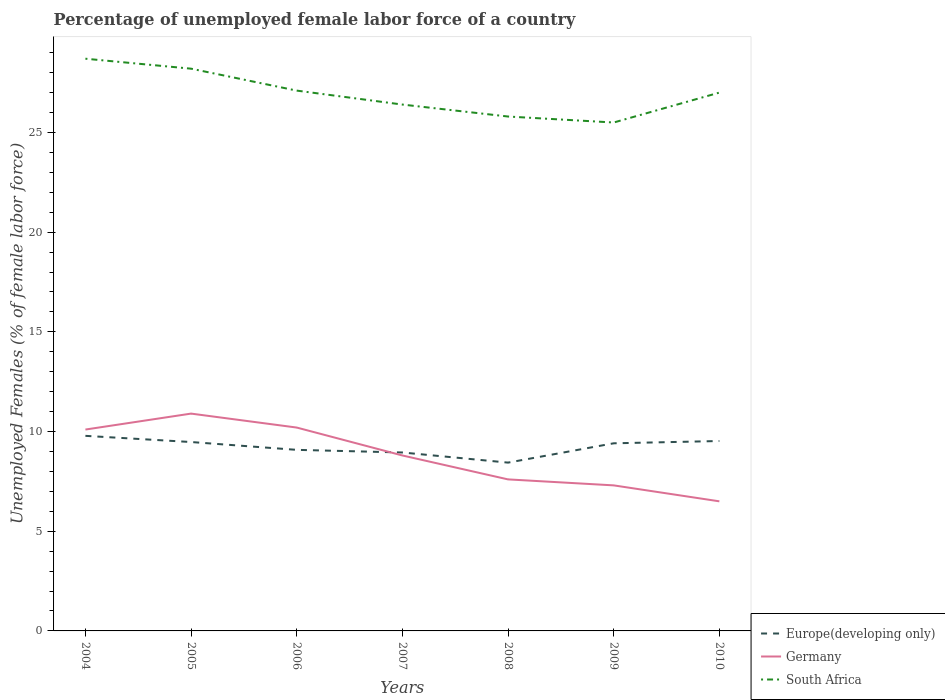How many different coloured lines are there?
Offer a very short reply. 3. Is the number of lines equal to the number of legend labels?
Your answer should be compact. Yes. In which year was the percentage of unemployed female labor force in Europe(developing only) maximum?
Your answer should be very brief. 2008. What is the total percentage of unemployed female labor force in Europe(developing only) in the graph?
Offer a terse response. -0.11. What is the difference between the highest and the second highest percentage of unemployed female labor force in Europe(developing only)?
Your answer should be compact. 1.34. Is the percentage of unemployed female labor force in South Africa strictly greater than the percentage of unemployed female labor force in Germany over the years?
Offer a very short reply. No. What is the difference between two consecutive major ticks on the Y-axis?
Give a very brief answer. 5. Are the values on the major ticks of Y-axis written in scientific E-notation?
Offer a terse response. No. Does the graph contain any zero values?
Give a very brief answer. No. Does the graph contain grids?
Your response must be concise. No. How many legend labels are there?
Offer a terse response. 3. How are the legend labels stacked?
Your answer should be very brief. Vertical. What is the title of the graph?
Keep it short and to the point. Percentage of unemployed female labor force of a country. Does "Cambodia" appear as one of the legend labels in the graph?
Your response must be concise. No. What is the label or title of the Y-axis?
Your response must be concise. Unemployed Females (% of female labor force). What is the Unemployed Females (% of female labor force) of Europe(developing only) in 2004?
Provide a succinct answer. 9.78. What is the Unemployed Females (% of female labor force) in Germany in 2004?
Your answer should be very brief. 10.1. What is the Unemployed Females (% of female labor force) in South Africa in 2004?
Your response must be concise. 28.7. What is the Unemployed Females (% of female labor force) of Europe(developing only) in 2005?
Make the answer very short. 9.47. What is the Unemployed Females (% of female labor force) in Germany in 2005?
Your answer should be compact. 10.9. What is the Unemployed Females (% of female labor force) in South Africa in 2005?
Offer a terse response. 28.2. What is the Unemployed Females (% of female labor force) of Europe(developing only) in 2006?
Provide a short and direct response. 9.08. What is the Unemployed Females (% of female labor force) in Germany in 2006?
Provide a succinct answer. 10.2. What is the Unemployed Females (% of female labor force) of South Africa in 2006?
Offer a terse response. 27.1. What is the Unemployed Females (% of female labor force) of Europe(developing only) in 2007?
Your response must be concise. 8.95. What is the Unemployed Females (% of female labor force) of Germany in 2007?
Give a very brief answer. 8.8. What is the Unemployed Females (% of female labor force) in South Africa in 2007?
Your answer should be compact. 26.4. What is the Unemployed Females (% of female labor force) in Europe(developing only) in 2008?
Make the answer very short. 8.44. What is the Unemployed Females (% of female labor force) in Germany in 2008?
Ensure brevity in your answer.  7.6. What is the Unemployed Females (% of female labor force) of South Africa in 2008?
Provide a short and direct response. 25.8. What is the Unemployed Females (% of female labor force) of Europe(developing only) in 2009?
Offer a very short reply. 9.41. What is the Unemployed Females (% of female labor force) in Germany in 2009?
Ensure brevity in your answer.  7.3. What is the Unemployed Females (% of female labor force) in South Africa in 2009?
Provide a short and direct response. 25.5. What is the Unemployed Females (% of female labor force) of Europe(developing only) in 2010?
Offer a terse response. 9.52. What is the Unemployed Females (% of female labor force) of South Africa in 2010?
Your response must be concise. 27. Across all years, what is the maximum Unemployed Females (% of female labor force) in Europe(developing only)?
Provide a succinct answer. 9.78. Across all years, what is the maximum Unemployed Females (% of female labor force) in Germany?
Your answer should be very brief. 10.9. Across all years, what is the maximum Unemployed Females (% of female labor force) in South Africa?
Give a very brief answer. 28.7. Across all years, what is the minimum Unemployed Females (% of female labor force) of Europe(developing only)?
Your response must be concise. 8.44. Across all years, what is the minimum Unemployed Females (% of female labor force) in Germany?
Give a very brief answer. 6.5. What is the total Unemployed Females (% of female labor force) in Europe(developing only) in the graph?
Ensure brevity in your answer.  64.67. What is the total Unemployed Females (% of female labor force) of Germany in the graph?
Make the answer very short. 61.4. What is the total Unemployed Females (% of female labor force) of South Africa in the graph?
Provide a succinct answer. 188.7. What is the difference between the Unemployed Females (% of female labor force) of Europe(developing only) in 2004 and that in 2005?
Your answer should be very brief. 0.31. What is the difference between the Unemployed Females (% of female labor force) in South Africa in 2004 and that in 2005?
Provide a succinct answer. 0.5. What is the difference between the Unemployed Females (% of female labor force) in Europe(developing only) in 2004 and that in 2006?
Provide a short and direct response. 0.7. What is the difference between the Unemployed Females (% of female labor force) in South Africa in 2004 and that in 2006?
Ensure brevity in your answer.  1.6. What is the difference between the Unemployed Females (% of female labor force) in Europe(developing only) in 2004 and that in 2007?
Give a very brief answer. 0.83. What is the difference between the Unemployed Females (% of female labor force) in Germany in 2004 and that in 2007?
Make the answer very short. 1.3. What is the difference between the Unemployed Females (% of female labor force) in Europe(developing only) in 2004 and that in 2008?
Keep it short and to the point. 1.34. What is the difference between the Unemployed Females (% of female labor force) in Germany in 2004 and that in 2008?
Provide a succinct answer. 2.5. What is the difference between the Unemployed Females (% of female labor force) in South Africa in 2004 and that in 2008?
Ensure brevity in your answer.  2.9. What is the difference between the Unemployed Females (% of female labor force) in Europe(developing only) in 2004 and that in 2009?
Your answer should be very brief. 0.37. What is the difference between the Unemployed Females (% of female labor force) in Germany in 2004 and that in 2009?
Provide a succinct answer. 2.8. What is the difference between the Unemployed Females (% of female labor force) in South Africa in 2004 and that in 2009?
Provide a short and direct response. 3.2. What is the difference between the Unemployed Females (% of female labor force) in Europe(developing only) in 2004 and that in 2010?
Your answer should be very brief. 0.26. What is the difference between the Unemployed Females (% of female labor force) in South Africa in 2004 and that in 2010?
Ensure brevity in your answer.  1.7. What is the difference between the Unemployed Females (% of female labor force) of Europe(developing only) in 2005 and that in 2006?
Your response must be concise. 0.39. What is the difference between the Unemployed Females (% of female labor force) of Germany in 2005 and that in 2006?
Your response must be concise. 0.7. What is the difference between the Unemployed Females (% of female labor force) in South Africa in 2005 and that in 2006?
Offer a very short reply. 1.1. What is the difference between the Unemployed Females (% of female labor force) in Europe(developing only) in 2005 and that in 2007?
Your answer should be very brief. 0.52. What is the difference between the Unemployed Females (% of female labor force) in Germany in 2005 and that in 2007?
Your answer should be compact. 2.1. What is the difference between the Unemployed Females (% of female labor force) of Europe(developing only) in 2005 and that in 2008?
Your response must be concise. 1.03. What is the difference between the Unemployed Females (% of female labor force) in Germany in 2005 and that in 2008?
Make the answer very short. 3.3. What is the difference between the Unemployed Females (% of female labor force) of South Africa in 2005 and that in 2008?
Offer a very short reply. 2.4. What is the difference between the Unemployed Females (% of female labor force) in Europe(developing only) in 2005 and that in 2009?
Keep it short and to the point. 0.06. What is the difference between the Unemployed Females (% of female labor force) in Germany in 2005 and that in 2009?
Give a very brief answer. 3.6. What is the difference between the Unemployed Females (% of female labor force) in South Africa in 2005 and that in 2009?
Offer a very short reply. 2.7. What is the difference between the Unemployed Females (% of female labor force) of Europe(developing only) in 2005 and that in 2010?
Offer a very short reply. -0.05. What is the difference between the Unemployed Females (% of female labor force) of Germany in 2005 and that in 2010?
Provide a succinct answer. 4.4. What is the difference between the Unemployed Females (% of female labor force) of South Africa in 2005 and that in 2010?
Your response must be concise. 1.2. What is the difference between the Unemployed Females (% of female labor force) of Europe(developing only) in 2006 and that in 2007?
Your answer should be compact. 0.13. What is the difference between the Unemployed Females (% of female labor force) in Europe(developing only) in 2006 and that in 2008?
Keep it short and to the point. 0.64. What is the difference between the Unemployed Females (% of female labor force) of Germany in 2006 and that in 2008?
Your answer should be very brief. 2.6. What is the difference between the Unemployed Females (% of female labor force) in Europe(developing only) in 2006 and that in 2009?
Your response must be concise. -0.33. What is the difference between the Unemployed Females (% of female labor force) in Germany in 2006 and that in 2009?
Give a very brief answer. 2.9. What is the difference between the Unemployed Females (% of female labor force) of Europe(developing only) in 2006 and that in 2010?
Keep it short and to the point. -0.44. What is the difference between the Unemployed Females (% of female labor force) of South Africa in 2006 and that in 2010?
Offer a terse response. 0.1. What is the difference between the Unemployed Females (% of female labor force) of Europe(developing only) in 2007 and that in 2008?
Give a very brief answer. 0.51. What is the difference between the Unemployed Females (% of female labor force) in Germany in 2007 and that in 2008?
Provide a short and direct response. 1.2. What is the difference between the Unemployed Females (% of female labor force) in South Africa in 2007 and that in 2008?
Your response must be concise. 0.6. What is the difference between the Unemployed Females (% of female labor force) of Europe(developing only) in 2007 and that in 2009?
Keep it short and to the point. -0.46. What is the difference between the Unemployed Females (% of female labor force) of South Africa in 2007 and that in 2009?
Make the answer very short. 0.9. What is the difference between the Unemployed Females (% of female labor force) in Europe(developing only) in 2007 and that in 2010?
Provide a short and direct response. -0.58. What is the difference between the Unemployed Females (% of female labor force) of Germany in 2007 and that in 2010?
Offer a terse response. 2.3. What is the difference between the Unemployed Females (% of female labor force) of Europe(developing only) in 2008 and that in 2009?
Your response must be concise. -0.97. What is the difference between the Unemployed Females (% of female labor force) of South Africa in 2008 and that in 2009?
Your answer should be very brief. 0.3. What is the difference between the Unemployed Females (% of female labor force) of Europe(developing only) in 2008 and that in 2010?
Offer a very short reply. -1.08. What is the difference between the Unemployed Females (% of female labor force) in South Africa in 2008 and that in 2010?
Offer a terse response. -1.2. What is the difference between the Unemployed Females (% of female labor force) in Europe(developing only) in 2009 and that in 2010?
Give a very brief answer. -0.11. What is the difference between the Unemployed Females (% of female labor force) of Germany in 2009 and that in 2010?
Your answer should be compact. 0.8. What is the difference between the Unemployed Females (% of female labor force) of South Africa in 2009 and that in 2010?
Ensure brevity in your answer.  -1.5. What is the difference between the Unemployed Females (% of female labor force) in Europe(developing only) in 2004 and the Unemployed Females (% of female labor force) in Germany in 2005?
Keep it short and to the point. -1.12. What is the difference between the Unemployed Females (% of female labor force) of Europe(developing only) in 2004 and the Unemployed Females (% of female labor force) of South Africa in 2005?
Your answer should be compact. -18.42. What is the difference between the Unemployed Females (% of female labor force) in Germany in 2004 and the Unemployed Females (% of female labor force) in South Africa in 2005?
Your answer should be compact. -18.1. What is the difference between the Unemployed Females (% of female labor force) in Europe(developing only) in 2004 and the Unemployed Females (% of female labor force) in Germany in 2006?
Offer a very short reply. -0.42. What is the difference between the Unemployed Females (% of female labor force) in Europe(developing only) in 2004 and the Unemployed Females (% of female labor force) in South Africa in 2006?
Provide a short and direct response. -17.32. What is the difference between the Unemployed Females (% of female labor force) in Germany in 2004 and the Unemployed Females (% of female labor force) in South Africa in 2006?
Offer a very short reply. -17. What is the difference between the Unemployed Females (% of female labor force) in Europe(developing only) in 2004 and the Unemployed Females (% of female labor force) in Germany in 2007?
Your answer should be compact. 0.98. What is the difference between the Unemployed Females (% of female labor force) in Europe(developing only) in 2004 and the Unemployed Females (% of female labor force) in South Africa in 2007?
Offer a terse response. -16.62. What is the difference between the Unemployed Females (% of female labor force) in Germany in 2004 and the Unemployed Females (% of female labor force) in South Africa in 2007?
Give a very brief answer. -16.3. What is the difference between the Unemployed Females (% of female labor force) in Europe(developing only) in 2004 and the Unemployed Females (% of female labor force) in Germany in 2008?
Your answer should be compact. 2.18. What is the difference between the Unemployed Females (% of female labor force) of Europe(developing only) in 2004 and the Unemployed Females (% of female labor force) of South Africa in 2008?
Provide a short and direct response. -16.02. What is the difference between the Unemployed Females (% of female labor force) in Germany in 2004 and the Unemployed Females (% of female labor force) in South Africa in 2008?
Offer a terse response. -15.7. What is the difference between the Unemployed Females (% of female labor force) in Europe(developing only) in 2004 and the Unemployed Females (% of female labor force) in Germany in 2009?
Your response must be concise. 2.48. What is the difference between the Unemployed Females (% of female labor force) of Europe(developing only) in 2004 and the Unemployed Females (% of female labor force) of South Africa in 2009?
Ensure brevity in your answer.  -15.72. What is the difference between the Unemployed Females (% of female labor force) in Germany in 2004 and the Unemployed Females (% of female labor force) in South Africa in 2009?
Your answer should be very brief. -15.4. What is the difference between the Unemployed Females (% of female labor force) in Europe(developing only) in 2004 and the Unemployed Females (% of female labor force) in Germany in 2010?
Give a very brief answer. 3.28. What is the difference between the Unemployed Females (% of female labor force) of Europe(developing only) in 2004 and the Unemployed Females (% of female labor force) of South Africa in 2010?
Keep it short and to the point. -17.22. What is the difference between the Unemployed Females (% of female labor force) in Germany in 2004 and the Unemployed Females (% of female labor force) in South Africa in 2010?
Provide a succinct answer. -16.9. What is the difference between the Unemployed Females (% of female labor force) in Europe(developing only) in 2005 and the Unemployed Females (% of female labor force) in Germany in 2006?
Offer a terse response. -0.73. What is the difference between the Unemployed Females (% of female labor force) of Europe(developing only) in 2005 and the Unemployed Females (% of female labor force) of South Africa in 2006?
Offer a very short reply. -17.63. What is the difference between the Unemployed Females (% of female labor force) of Germany in 2005 and the Unemployed Females (% of female labor force) of South Africa in 2006?
Your answer should be compact. -16.2. What is the difference between the Unemployed Females (% of female labor force) in Europe(developing only) in 2005 and the Unemployed Females (% of female labor force) in Germany in 2007?
Give a very brief answer. 0.67. What is the difference between the Unemployed Females (% of female labor force) in Europe(developing only) in 2005 and the Unemployed Females (% of female labor force) in South Africa in 2007?
Make the answer very short. -16.93. What is the difference between the Unemployed Females (% of female labor force) in Germany in 2005 and the Unemployed Females (% of female labor force) in South Africa in 2007?
Keep it short and to the point. -15.5. What is the difference between the Unemployed Females (% of female labor force) of Europe(developing only) in 2005 and the Unemployed Females (% of female labor force) of Germany in 2008?
Ensure brevity in your answer.  1.87. What is the difference between the Unemployed Females (% of female labor force) in Europe(developing only) in 2005 and the Unemployed Females (% of female labor force) in South Africa in 2008?
Your answer should be very brief. -16.33. What is the difference between the Unemployed Females (% of female labor force) of Germany in 2005 and the Unemployed Females (% of female labor force) of South Africa in 2008?
Your answer should be compact. -14.9. What is the difference between the Unemployed Females (% of female labor force) in Europe(developing only) in 2005 and the Unemployed Females (% of female labor force) in Germany in 2009?
Make the answer very short. 2.17. What is the difference between the Unemployed Females (% of female labor force) in Europe(developing only) in 2005 and the Unemployed Females (% of female labor force) in South Africa in 2009?
Your response must be concise. -16.03. What is the difference between the Unemployed Females (% of female labor force) in Germany in 2005 and the Unemployed Females (% of female labor force) in South Africa in 2009?
Provide a succinct answer. -14.6. What is the difference between the Unemployed Females (% of female labor force) in Europe(developing only) in 2005 and the Unemployed Females (% of female labor force) in Germany in 2010?
Your response must be concise. 2.97. What is the difference between the Unemployed Females (% of female labor force) of Europe(developing only) in 2005 and the Unemployed Females (% of female labor force) of South Africa in 2010?
Make the answer very short. -17.53. What is the difference between the Unemployed Females (% of female labor force) in Germany in 2005 and the Unemployed Females (% of female labor force) in South Africa in 2010?
Offer a very short reply. -16.1. What is the difference between the Unemployed Females (% of female labor force) in Europe(developing only) in 2006 and the Unemployed Females (% of female labor force) in Germany in 2007?
Provide a succinct answer. 0.28. What is the difference between the Unemployed Females (% of female labor force) in Europe(developing only) in 2006 and the Unemployed Females (% of female labor force) in South Africa in 2007?
Your response must be concise. -17.32. What is the difference between the Unemployed Females (% of female labor force) of Germany in 2006 and the Unemployed Females (% of female labor force) of South Africa in 2007?
Make the answer very short. -16.2. What is the difference between the Unemployed Females (% of female labor force) of Europe(developing only) in 2006 and the Unemployed Females (% of female labor force) of Germany in 2008?
Your answer should be very brief. 1.48. What is the difference between the Unemployed Females (% of female labor force) in Europe(developing only) in 2006 and the Unemployed Females (% of female labor force) in South Africa in 2008?
Provide a succinct answer. -16.72. What is the difference between the Unemployed Females (% of female labor force) in Germany in 2006 and the Unemployed Females (% of female labor force) in South Africa in 2008?
Ensure brevity in your answer.  -15.6. What is the difference between the Unemployed Females (% of female labor force) of Europe(developing only) in 2006 and the Unemployed Females (% of female labor force) of Germany in 2009?
Your answer should be compact. 1.78. What is the difference between the Unemployed Females (% of female labor force) in Europe(developing only) in 2006 and the Unemployed Females (% of female labor force) in South Africa in 2009?
Your answer should be compact. -16.42. What is the difference between the Unemployed Females (% of female labor force) in Germany in 2006 and the Unemployed Females (% of female labor force) in South Africa in 2009?
Your answer should be compact. -15.3. What is the difference between the Unemployed Females (% of female labor force) of Europe(developing only) in 2006 and the Unemployed Females (% of female labor force) of Germany in 2010?
Your answer should be very brief. 2.58. What is the difference between the Unemployed Females (% of female labor force) of Europe(developing only) in 2006 and the Unemployed Females (% of female labor force) of South Africa in 2010?
Make the answer very short. -17.92. What is the difference between the Unemployed Females (% of female labor force) in Germany in 2006 and the Unemployed Females (% of female labor force) in South Africa in 2010?
Provide a succinct answer. -16.8. What is the difference between the Unemployed Females (% of female labor force) in Europe(developing only) in 2007 and the Unemployed Females (% of female labor force) in Germany in 2008?
Ensure brevity in your answer.  1.35. What is the difference between the Unemployed Females (% of female labor force) of Europe(developing only) in 2007 and the Unemployed Females (% of female labor force) of South Africa in 2008?
Your answer should be very brief. -16.85. What is the difference between the Unemployed Females (% of female labor force) of Germany in 2007 and the Unemployed Females (% of female labor force) of South Africa in 2008?
Provide a succinct answer. -17. What is the difference between the Unemployed Females (% of female labor force) in Europe(developing only) in 2007 and the Unemployed Females (% of female labor force) in Germany in 2009?
Provide a succinct answer. 1.65. What is the difference between the Unemployed Females (% of female labor force) of Europe(developing only) in 2007 and the Unemployed Females (% of female labor force) of South Africa in 2009?
Offer a very short reply. -16.55. What is the difference between the Unemployed Females (% of female labor force) of Germany in 2007 and the Unemployed Females (% of female labor force) of South Africa in 2009?
Keep it short and to the point. -16.7. What is the difference between the Unemployed Females (% of female labor force) of Europe(developing only) in 2007 and the Unemployed Females (% of female labor force) of Germany in 2010?
Offer a very short reply. 2.45. What is the difference between the Unemployed Females (% of female labor force) of Europe(developing only) in 2007 and the Unemployed Females (% of female labor force) of South Africa in 2010?
Offer a very short reply. -18.05. What is the difference between the Unemployed Females (% of female labor force) in Germany in 2007 and the Unemployed Females (% of female labor force) in South Africa in 2010?
Give a very brief answer. -18.2. What is the difference between the Unemployed Females (% of female labor force) in Europe(developing only) in 2008 and the Unemployed Females (% of female labor force) in Germany in 2009?
Offer a terse response. 1.14. What is the difference between the Unemployed Females (% of female labor force) of Europe(developing only) in 2008 and the Unemployed Females (% of female labor force) of South Africa in 2009?
Your response must be concise. -17.06. What is the difference between the Unemployed Females (% of female labor force) in Germany in 2008 and the Unemployed Females (% of female labor force) in South Africa in 2009?
Offer a terse response. -17.9. What is the difference between the Unemployed Females (% of female labor force) in Europe(developing only) in 2008 and the Unemployed Females (% of female labor force) in Germany in 2010?
Ensure brevity in your answer.  1.94. What is the difference between the Unemployed Females (% of female labor force) in Europe(developing only) in 2008 and the Unemployed Females (% of female labor force) in South Africa in 2010?
Keep it short and to the point. -18.56. What is the difference between the Unemployed Females (% of female labor force) in Germany in 2008 and the Unemployed Females (% of female labor force) in South Africa in 2010?
Your answer should be very brief. -19.4. What is the difference between the Unemployed Females (% of female labor force) in Europe(developing only) in 2009 and the Unemployed Females (% of female labor force) in Germany in 2010?
Your answer should be very brief. 2.91. What is the difference between the Unemployed Females (% of female labor force) of Europe(developing only) in 2009 and the Unemployed Females (% of female labor force) of South Africa in 2010?
Your answer should be compact. -17.59. What is the difference between the Unemployed Females (% of female labor force) of Germany in 2009 and the Unemployed Females (% of female labor force) of South Africa in 2010?
Provide a succinct answer. -19.7. What is the average Unemployed Females (% of female labor force) in Europe(developing only) per year?
Your response must be concise. 9.24. What is the average Unemployed Females (% of female labor force) of Germany per year?
Give a very brief answer. 8.77. What is the average Unemployed Females (% of female labor force) of South Africa per year?
Your answer should be very brief. 26.96. In the year 2004, what is the difference between the Unemployed Females (% of female labor force) in Europe(developing only) and Unemployed Females (% of female labor force) in Germany?
Give a very brief answer. -0.32. In the year 2004, what is the difference between the Unemployed Females (% of female labor force) of Europe(developing only) and Unemployed Females (% of female labor force) of South Africa?
Your answer should be very brief. -18.92. In the year 2004, what is the difference between the Unemployed Females (% of female labor force) in Germany and Unemployed Females (% of female labor force) in South Africa?
Offer a very short reply. -18.6. In the year 2005, what is the difference between the Unemployed Females (% of female labor force) of Europe(developing only) and Unemployed Females (% of female labor force) of Germany?
Make the answer very short. -1.43. In the year 2005, what is the difference between the Unemployed Females (% of female labor force) in Europe(developing only) and Unemployed Females (% of female labor force) in South Africa?
Make the answer very short. -18.73. In the year 2005, what is the difference between the Unemployed Females (% of female labor force) of Germany and Unemployed Females (% of female labor force) of South Africa?
Offer a terse response. -17.3. In the year 2006, what is the difference between the Unemployed Females (% of female labor force) in Europe(developing only) and Unemployed Females (% of female labor force) in Germany?
Provide a succinct answer. -1.12. In the year 2006, what is the difference between the Unemployed Females (% of female labor force) of Europe(developing only) and Unemployed Females (% of female labor force) of South Africa?
Ensure brevity in your answer.  -18.02. In the year 2006, what is the difference between the Unemployed Females (% of female labor force) in Germany and Unemployed Females (% of female labor force) in South Africa?
Keep it short and to the point. -16.9. In the year 2007, what is the difference between the Unemployed Females (% of female labor force) in Europe(developing only) and Unemployed Females (% of female labor force) in Germany?
Your answer should be very brief. 0.15. In the year 2007, what is the difference between the Unemployed Females (% of female labor force) of Europe(developing only) and Unemployed Females (% of female labor force) of South Africa?
Your response must be concise. -17.45. In the year 2007, what is the difference between the Unemployed Females (% of female labor force) in Germany and Unemployed Females (% of female labor force) in South Africa?
Provide a succinct answer. -17.6. In the year 2008, what is the difference between the Unemployed Females (% of female labor force) of Europe(developing only) and Unemployed Females (% of female labor force) of Germany?
Offer a very short reply. 0.84. In the year 2008, what is the difference between the Unemployed Females (% of female labor force) in Europe(developing only) and Unemployed Females (% of female labor force) in South Africa?
Your answer should be very brief. -17.36. In the year 2008, what is the difference between the Unemployed Females (% of female labor force) of Germany and Unemployed Females (% of female labor force) of South Africa?
Offer a terse response. -18.2. In the year 2009, what is the difference between the Unemployed Females (% of female labor force) in Europe(developing only) and Unemployed Females (% of female labor force) in Germany?
Provide a succinct answer. 2.11. In the year 2009, what is the difference between the Unemployed Females (% of female labor force) in Europe(developing only) and Unemployed Females (% of female labor force) in South Africa?
Ensure brevity in your answer.  -16.09. In the year 2009, what is the difference between the Unemployed Females (% of female labor force) of Germany and Unemployed Females (% of female labor force) of South Africa?
Ensure brevity in your answer.  -18.2. In the year 2010, what is the difference between the Unemployed Females (% of female labor force) of Europe(developing only) and Unemployed Females (% of female labor force) of Germany?
Provide a short and direct response. 3.02. In the year 2010, what is the difference between the Unemployed Females (% of female labor force) in Europe(developing only) and Unemployed Females (% of female labor force) in South Africa?
Your answer should be very brief. -17.48. In the year 2010, what is the difference between the Unemployed Females (% of female labor force) of Germany and Unemployed Females (% of female labor force) of South Africa?
Offer a very short reply. -20.5. What is the ratio of the Unemployed Females (% of female labor force) of Europe(developing only) in 2004 to that in 2005?
Offer a very short reply. 1.03. What is the ratio of the Unemployed Females (% of female labor force) in Germany in 2004 to that in 2005?
Provide a short and direct response. 0.93. What is the ratio of the Unemployed Females (% of female labor force) of South Africa in 2004 to that in 2005?
Keep it short and to the point. 1.02. What is the ratio of the Unemployed Females (% of female labor force) of Europe(developing only) in 2004 to that in 2006?
Provide a short and direct response. 1.08. What is the ratio of the Unemployed Females (% of female labor force) in Germany in 2004 to that in 2006?
Offer a very short reply. 0.99. What is the ratio of the Unemployed Females (% of female labor force) of South Africa in 2004 to that in 2006?
Your response must be concise. 1.06. What is the ratio of the Unemployed Females (% of female labor force) of Europe(developing only) in 2004 to that in 2007?
Provide a short and direct response. 1.09. What is the ratio of the Unemployed Females (% of female labor force) in Germany in 2004 to that in 2007?
Provide a short and direct response. 1.15. What is the ratio of the Unemployed Females (% of female labor force) of South Africa in 2004 to that in 2007?
Offer a terse response. 1.09. What is the ratio of the Unemployed Females (% of female labor force) of Europe(developing only) in 2004 to that in 2008?
Your answer should be very brief. 1.16. What is the ratio of the Unemployed Females (% of female labor force) of Germany in 2004 to that in 2008?
Your answer should be very brief. 1.33. What is the ratio of the Unemployed Females (% of female labor force) in South Africa in 2004 to that in 2008?
Your response must be concise. 1.11. What is the ratio of the Unemployed Females (% of female labor force) in Europe(developing only) in 2004 to that in 2009?
Your answer should be very brief. 1.04. What is the ratio of the Unemployed Females (% of female labor force) of Germany in 2004 to that in 2009?
Make the answer very short. 1.38. What is the ratio of the Unemployed Females (% of female labor force) of South Africa in 2004 to that in 2009?
Your response must be concise. 1.13. What is the ratio of the Unemployed Females (% of female labor force) of Europe(developing only) in 2004 to that in 2010?
Provide a short and direct response. 1.03. What is the ratio of the Unemployed Females (% of female labor force) of Germany in 2004 to that in 2010?
Make the answer very short. 1.55. What is the ratio of the Unemployed Females (% of female labor force) in South Africa in 2004 to that in 2010?
Provide a succinct answer. 1.06. What is the ratio of the Unemployed Females (% of female labor force) in Europe(developing only) in 2005 to that in 2006?
Keep it short and to the point. 1.04. What is the ratio of the Unemployed Females (% of female labor force) of Germany in 2005 to that in 2006?
Make the answer very short. 1.07. What is the ratio of the Unemployed Females (% of female labor force) in South Africa in 2005 to that in 2006?
Offer a terse response. 1.04. What is the ratio of the Unemployed Females (% of female labor force) of Europe(developing only) in 2005 to that in 2007?
Make the answer very short. 1.06. What is the ratio of the Unemployed Females (% of female labor force) in Germany in 2005 to that in 2007?
Give a very brief answer. 1.24. What is the ratio of the Unemployed Females (% of female labor force) of South Africa in 2005 to that in 2007?
Give a very brief answer. 1.07. What is the ratio of the Unemployed Females (% of female labor force) of Europe(developing only) in 2005 to that in 2008?
Offer a terse response. 1.12. What is the ratio of the Unemployed Females (% of female labor force) of Germany in 2005 to that in 2008?
Keep it short and to the point. 1.43. What is the ratio of the Unemployed Females (% of female labor force) in South Africa in 2005 to that in 2008?
Your answer should be compact. 1.09. What is the ratio of the Unemployed Females (% of female labor force) of Europe(developing only) in 2005 to that in 2009?
Make the answer very short. 1.01. What is the ratio of the Unemployed Females (% of female labor force) of Germany in 2005 to that in 2009?
Your response must be concise. 1.49. What is the ratio of the Unemployed Females (% of female labor force) in South Africa in 2005 to that in 2009?
Your response must be concise. 1.11. What is the ratio of the Unemployed Females (% of female labor force) in Germany in 2005 to that in 2010?
Ensure brevity in your answer.  1.68. What is the ratio of the Unemployed Females (% of female labor force) of South Africa in 2005 to that in 2010?
Your answer should be compact. 1.04. What is the ratio of the Unemployed Females (% of female labor force) of Europe(developing only) in 2006 to that in 2007?
Your answer should be very brief. 1.01. What is the ratio of the Unemployed Females (% of female labor force) in Germany in 2006 to that in 2007?
Your response must be concise. 1.16. What is the ratio of the Unemployed Females (% of female labor force) of South Africa in 2006 to that in 2007?
Keep it short and to the point. 1.03. What is the ratio of the Unemployed Females (% of female labor force) of Europe(developing only) in 2006 to that in 2008?
Provide a short and direct response. 1.08. What is the ratio of the Unemployed Females (% of female labor force) of Germany in 2006 to that in 2008?
Your answer should be compact. 1.34. What is the ratio of the Unemployed Females (% of female labor force) in South Africa in 2006 to that in 2008?
Make the answer very short. 1.05. What is the ratio of the Unemployed Females (% of female labor force) of Europe(developing only) in 2006 to that in 2009?
Make the answer very short. 0.97. What is the ratio of the Unemployed Females (% of female labor force) of Germany in 2006 to that in 2009?
Offer a terse response. 1.4. What is the ratio of the Unemployed Females (% of female labor force) in South Africa in 2006 to that in 2009?
Provide a short and direct response. 1.06. What is the ratio of the Unemployed Females (% of female labor force) of Europe(developing only) in 2006 to that in 2010?
Make the answer very short. 0.95. What is the ratio of the Unemployed Females (% of female labor force) in Germany in 2006 to that in 2010?
Your response must be concise. 1.57. What is the ratio of the Unemployed Females (% of female labor force) in Europe(developing only) in 2007 to that in 2008?
Ensure brevity in your answer.  1.06. What is the ratio of the Unemployed Females (% of female labor force) in Germany in 2007 to that in 2008?
Your answer should be very brief. 1.16. What is the ratio of the Unemployed Females (% of female labor force) in South Africa in 2007 to that in 2008?
Your answer should be very brief. 1.02. What is the ratio of the Unemployed Females (% of female labor force) of Europe(developing only) in 2007 to that in 2009?
Offer a very short reply. 0.95. What is the ratio of the Unemployed Females (% of female labor force) of Germany in 2007 to that in 2009?
Offer a terse response. 1.21. What is the ratio of the Unemployed Females (% of female labor force) of South Africa in 2007 to that in 2009?
Keep it short and to the point. 1.04. What is the ratio of the Unemployed Females (% of female labor force) in Europe(developing only) in 2007 to that in 2010?
Offer a very short reply. 0.94. What is the ratio of the Unemployed Females (% of female labor force) of Germany in 2007 to that in 2010?
Your answer should be compact. 1.35. What is the ratio of the Unemployed Females (% of female labor force) in South Africa in 2007 to that in 2010?
Offer a very short reply. 0.98. What is the ratio of the Unemployed Females (% of female labor force) in Europe(developing only) in 2008 to that in 2009?
Your answer should be very brief. 0.9. What is the ratio of the Unemployed Females (% of female labor force) in Germany in 2008 to that in 2009?
Your response must be concise. 1.04. What is the ratio of the Unemployed Females (% of female labor force) of South Africa in 2008 to that in 2009?
Give a very brief answer. 1.01. What is the ratio of the Unemployed Females (% of female labor force) of Europe(developing only) in 2008 to that in 2010?
Provide a succinct answer. 0.89. What is the ratio of the Unemployed Females (% of female labor force) in Germany in 2008 to that in 2010?
Your answer should be compact. 1.17. What is the ratio of the Unemployed Females (% of female labor force) of South Africa in 2008 to that in 2010?
Provide a short and direct response. 0.96. What is the ratio of the Unemployed Females (% of female labor force) of Europe(developing only) in 2009 to that in 2010?
Make the answer very short. 0.99. What is the ratio of the Unemployed Females (% of female labor force) in Germany in 2009 to that in 2010?
Give a very brief answer. 1.12. What is the ratio of the Unemployed Females (% of female labor force) of South Africa in 2009 to that in 2010?
Make the answer very short. 0.94. What is the difference between the highest and the second highest Unemployed Females (% of female labor force) of Europe(developing only)?
Keep it short and to the point. 0.26. What is the difference between the highest and the second highest Unemployed Females (% of female labor force) of South Africa?
Make the answer very short. 0.5. What is the difference between the highest and the lowest Unemployed Females (% of female labor force) of Europe(developing only)?
Your answer should be compact. 1.34. 